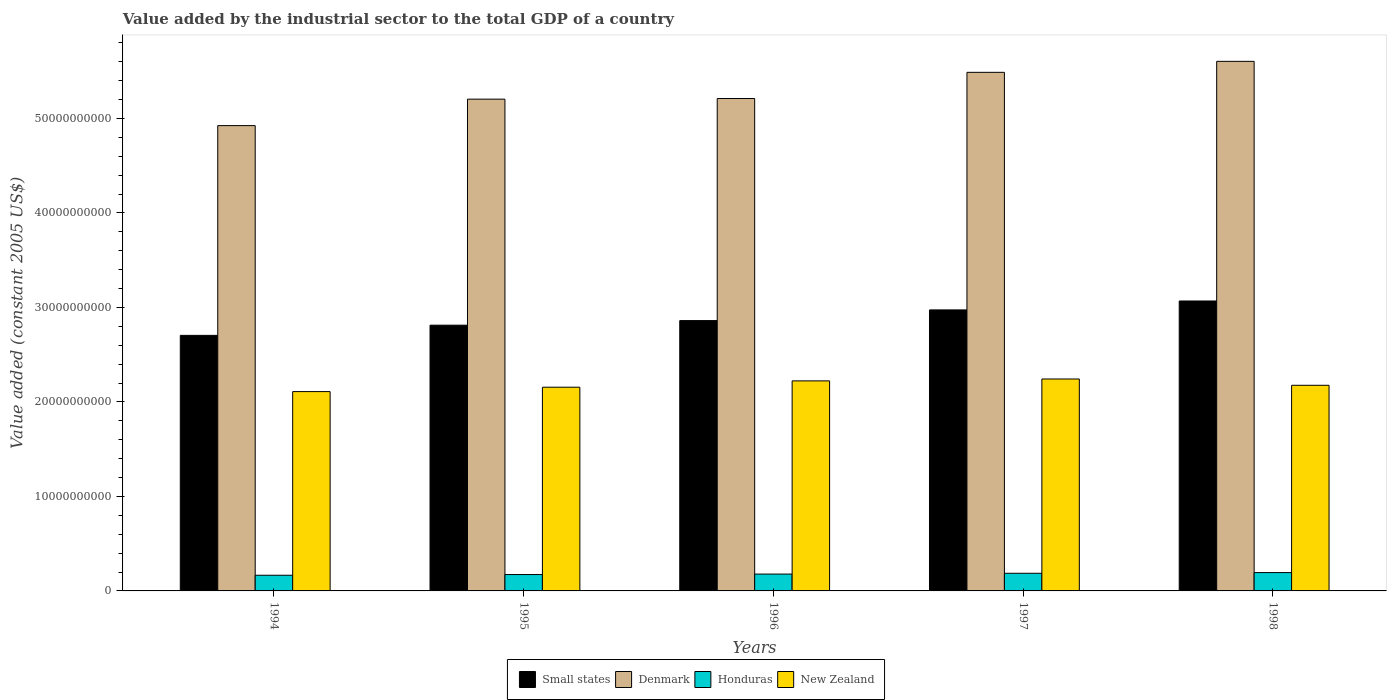How many different coloured bars are there?
Your answer should be compact. 4. Are the number of bars on each tick of the X-axis equal?
Offer a terse response. Yes. How many bars are there on the 2nd tick from the left?
Your answer should be compact. 4. In how many cases, is the number of bars for a given year not equal to the number of legend labels?
Provide a short and direct response. 0. What is the value added by the industrial sector in Small states in 1997?
Give a very brief answer. 2.97e+1. Across all years, what is the maximum value added by the industrial sector in Small states?
Provide a succinct answer. 3.07e+1. Across all years, what is the minimum value added by the industrial sector in Small states?
Provide a succinct answer. 2.70e+1. In which year was the value added by the industrial sector in Denmark minimum?
Offer a terse response. 1994. What is the total value added by the industrial sector in New Zealand in the graph?
Keep it short and to the point. 1.09e+11. What is the difference between the value added by the industrial sector in Small states in 1994 and that in 1997?
Your answer should be compact. -2.69e+09. What is the difference between the value added by the industrial sector in Denmark in 1998 and the value added by the industrial sector in Honduras in 1994?
Your response must be concise. 5.44e+1. What is the average value added by the industrial sector in New Zealand per year?
Make the answer very short. 2.18e+1. In the year 1996, what is the difference between the value added by the industrial sector in Denmark and value added by the industrial sector in Small states?
Your response must be concise. 2.35e+1. In how many years, is the value added by the industrial sector in Small states greater than 30000000000 US$?
Give a very brief answer. 1. What is the ratio of the value added by the industrial sector in New Zealand in 1994 to that in 1995?
Offer a very short reply. 0.98. Is the difference between the value added by the industrial sector in Denmark in 1997 and 1998 greater than the difference between the value added by the industrial sector in Small states in 1997 and 1998?
Your answer should be compact. No. What is the difference between the highest and the second highest value added by the industrial sector in Honduras?
Give a very brief answer. 7.31e+07. What is the difference between the highest and the lowest value added by the industrial sector in Honduras?
Your response must be concise. 2.81e+08. In how many years, is the value added by the industrial sector in New Zealand greater than the average value added by the industrial sector in New Zealand taken over all years?
Offer a terse response. 2. Is the sum of the value added by the industrial sector in Denmark in 1994 and 1998 greater than the maximum value added by the industrial sector in New Zealand across all years?
Give a very brief answer. Yes. Is it the case that in every year, the sum of the value added by the industrial sector in Denmark and value added by the industrial sector in New Zealand is greater than the sum of value added by the industrial sector in Honduras and value added by the industrial sector in Small states?
Keep it short and to the point. Yes. What does the 1st bar from the left in 1997 represents?
Your response must be concise. Small states. What does the 1st bar from the right in 1998 represents?
Offer a terse response. New Zealand. Are the values on the major ticks of Y-axis written in scientific E-notation?
Ensure brevity in your answer.  No. Where does the legend appear in the graph?
Your answer should be very brief. Bottom center. How many legend labels are there?
Your answer should be compact. 4. How are the legend labels stacked?
Your answer should be compact. Horizontal. What is the title of the graph?
Ensure brevity in your answer.  Value added by the industrial sector to the total GDP of a country. Does "Tajikistan" appear as one of the legend labels in the graph?
Offer a terse response. No. What is the label or title of the Y-axis?
Make the answer very short. Value added (constant 2005 US$). What is the Value added (constant 2005 US$) in Small states in 1994?
Make the answer very short. 2.70e+1. What is the Value added (constant 2005 US$) of Denmark in 1994?
Provide a short and direct response. 4.92e+1. What is the Value added (constant 2005 US$) in Honduras in 1994?
Give a very brief answer. 1.66e+09. What is the Value added (constant 2005 US$) of New Zealand in 1994?
Offer a very short reply. 2.11e+1. What is the Value added (constant 2005 US$) of Small states in 1995?
Make the answer very short. 2.81e+1. What is the Value added (constant 2005 US$) in Denmark in 1995?
Keep it short and to the point. 5.20e+1. What is the Value added (constant 2005 US$) in Honduras in 1995?
Your answer should be very brief. 1.73e+09. What is the Value added (constant 2005 US$) in New Zealand in 1995?
Your response must be concise. 2.16e+1. What is the Value added (constant 2005 US$) in Small states in 1996?
Provide a short and direct response. 2.86e+1. What is the Value added (constant 2005 US$) in Denmark in 1996?
Your answer should be compact. 5.21e+1. What is the Value added (constant 2005 US$) in Honduras in 1996?
Your response must be concise. 1.78e+09. What is the Value added (constant 2005 US$) of New Zealand in 1996?
Provide a short and direct response. 2.22e+1. What is the Value added (constant 2005 US$) in Small states in 1997?
Provide a succinct answer. 2.97e+1. What is the Value added (constant 2005 US$) in Denmark in 1997?
Your response must be concise. 5.49e+1. What is the Value added (constant 2005 US$) in Honduras in 1997?
Ensure brevity in your answer.  1.87e+09. What is the Value added (constant 2005 US$) of New Zealand in 1997?
Your answer should be very brief. 2.24e+1. What is the Value added (constant 2005 US$) in Small states in 1998?
Offer a terse response. 3.07e+1. What is the Value added (constant 2005 US$) of Denmark in 1998?
Your answer should be very brief. 5.60e+1. What is the Value added (constant 2005 US$) of Honduras in 1998?
Give a very brief answer. 1.94e+09. What is the Value added (constant 2005 US$) in New Zealand in 1998?
Give a very brief answer. 2.18e+1. Across all years, what is the maximum Value added (constant 2005 US$) of Small states?
Keep it short and to the point. 3.07e+1. Across all years, what is the maximum Value added (constant 2005 US$) in Denmark?
Your answer should be very brief. 5.60e+1. Across all years, what is the maximum Value added (constant 2005 US$) in Honduras?
Your response must be concise. 1.94e+09. Across all years, what is the maximum Value added (constant 2005 US$) of New Zealand?
Your response must be concise. 2.24e+1. Across all years, what is the minimum Value added (constant 2005 US$) in Small states?
Keep it short and to the point. 2.70e+1. Across all years, what is the minimum Value added (constant 2005 US$) of Denmark?
Your answer should be compact. 4.92e+1. Across all years, what is the minimum Value added (constant 2005 US$) in Honduras?
Provide a short and direct response. 1.66e+09. Across all years, what is the minimum Value added (constant 2005 US$) in New Zealand?
Make the answer very short. 2.11e+1. What is the total Value added (constant 2005 US$) in Small states in the graph?
Give a very brief answer. 1.44e+11. What is the total Value added (constant 2005 US$) of Denmark in the graph?
Offer a terse response. 2.64e+11. What is the total Value added (constant 2005 US$) in Honduras in the graph?
Ensure brevity in your answer.  8.98e+09. What is the total Value added (constant 2005 US$) in New Zealand in the graph?
Your answer should be compact. 1.09e+11. What is the difference between the Value added (constant 2005 US$) of Small states in 1994 and that in 1995?
Give a very brief answer. -1.08e+09. What is the difference between the Value added (constant 2005 US$) of Denmark in 1994 and that in 1995?
Provide a short and direct response. -2.80e+09. What is the difference between the Value added (constant 2005 US$) in Honduras in 1994 and that in 1995?
Ensure brevity in your answer.  -7.44e+07. What is the difference between the Value added (constant 2005 US$) of New Zealand in 1994 and that in 1995?
Your answer should be very brief. -4.64e+08. What is the difference between the Value added (constant 2005 US$) in Small states in 1994 and that in 1996?
Provide a short and direct response. -1.56e+09. What is the difference between the Value added (constant 2005 US$) in Denmark in 1994 and that in 1996?
Ensure brevity in your answer.  -2.87e+09. What is the difference between the Value added (constant 2005 US$) of Honduras in 1994 and that in 1996?
Give a very brief answer. -1.24e+08. What is the difference between the Value added (constant 2005 US$) of New Zealand in 1994 and that in 1996?
Your response must be concise. -1.13e+09. What is the difference between the Value added (constant 2005 US$) in Small states in 1994 and that in 1997?
Your answer should be very brief. -2.69e+09. What is the difference between the Value added (constant 2005 US$) in Denmark in 1994 and that in 1997?
Keep it short and to the point. -5.64e+09. What is the difference between the Value added (constant 2005 US$) in Honduras in 1994 and that in 1997?
Your answer should be very brief. -2.08e+08. What is the difference between the Value added (constant 2005 US$) in New Zealand in 1994 and that in 1997?
Your response must be concise. -1.33e+09. What is the difference between the Value added (constant 2005 US$) of Small states in 1994 and that in 1998?
Your answer should be very brief. -3.64e+09. What is the difference between the Value added (constant 2005 US$) in Denmark in 1994 and that in 1998?
Your response must be concise. -6.80e+09. What is the difference between the Value added (constant 2005 US$) of Honduras in 1994 and that in 1998?
Offer a terse response. -2.81e+08. What is the difference between the Value added (constant 2005 US$) of New Zealand in 1994 and that in 1998?
Provide a short and direct response. -6.67e+08. What is the difference between the Value added (constant 2005 US$) of Small states in 1995 and that in 1996?
Make the answer very short. -4.87e+08. What is the difference between the Value added (constant 2005 US$) in Denmark in 1995 and that in 1996?
Ensure brevity in your answer.  -6.66e+07. What is the difference between the Value added (constant 2005 US$) in Honduras in 1995 and that in 1996?
Your response must be concise. -5.00e+07. What is the difference between the Value added (constant 2005 US$) in New Zealand in 1995 and that in 1996?
Keep it short and to the point. -6.70e+08. What is the difference between the Value added (constant 2005 US$) in Small states in 1995 and that in 1997?
Your answer should be very brief. -1.62e+09. What is the difference between the Value added (constant 2005 US$) in Denmark in 1995 and that in 1997?
Your response must be concise. -2.84e+09. What is the difference between the Value added (constant 2005 US$) of Honduras in 1995 and that in 1997?
Provide a succinct answer. -1.33e+08. What is the difference between the Value added (constant 2005 US$) of New Zealand in 1995 and that in 1997?
Offer a terse response. -8.70e+08. What is the difference between the Value added (constant 2005 US$) in Small states in 1995 and that in 1998?
Your answer should be compact. -2.56e+09. What is the difference between the Value added (constant 2005 US$) in Denmark in 1995 and that in 1998?
Your answer should be compact. -4.00e+09. What is the difference between the Value added (constant 2005 US$) in Honduras in 1995 and that in 1998?
Give a very brief answer. -2.07e+08. What is the difference between the Value added (constant 2005 US$) in New Zealand in 1995 and that in 1998?
Offer a terse response. -2.04e+08. What is the difference between the Value added (constant 2005 US$) in Small states in 1996 and that in 1997?
Ensure brevity in your answer.  -1.13e+09. What is the difference between the Value added (constant 2005 US$) in Denmark in 1996 and that in 1997?
Your answer should be very brief. -2.77e+09. What is the difference between the Value added (constant 2005 US$) of Honduras in 1996 and that in 1997?
Provide a short and direct response. -8.34e+07. What is the difference between the Value added (constant 2005 US$) in New Zealand in 1996 and that in 1997?
Offer a terse response. -2.00e+08. What is the difference between the Value added (constant 2005 US$) of Small states in 1996 and that in 1998?
Ensure brevity in your answer.  -2.07e+09. What is the difference between the Value added (constant 2005 US$) in Denmark in 1996 and that in 1998?
Make the answer very short. -3.93e+09. What is the difference between the Value added (constant 2005 US$) of Honduras in 1996 and that in 1998?
Your answer should be compact. -1.57e+08. What is the difference between the Value added (constant 2005 US$) of New Zealand in 1996 and that in 1998?
Offer a terse response. 4.66e+08. What is the difference between the Value added (constant 2005 US$) of Small states in 1997 and that in 1998?
Your answer should be very brief. -9.44e+08. What is the difference between the Value added (constant 2005 US$) of Denmark in 1997 and that in 1998?
Provide a succinct answer. -1.16e+09. What is the difference between the Value added (constant 2005 US$) of Honduras in 1997 and that in 1998?
Your answer should be compact. -7.31e+07. What is the difference between the Value added (constant 2005 US$) of New Zealand in 1997 and that in 1998?
Offer a terse response. 6.66e+08. What is the difference between the Value added (constant 2005 US$) of Small states in 1994 and the Value added (constant 2005 US$) of Denmark in 1995?
Ensure brevity in your answer.  -2.50e+1. What is the difference between the Value added (constant 2005 US$) in Small states in 1994 and the Value added (constant 2005 US$) in Honduras in 1995?
Keep it short and to the point. 2.53e+1. What is the difference between the Value added (constant 2005 US$) in Small states in 1994 and the Value added (constant 2005 US$) in New Zealand in 1995?
Ensure brevity in your answer.  5.49e+09. What is the difference between the Value added (constant 2005 US$) in Denmark in 1994 and the Value added (constant 2005 US$) in Honduras in 1995?
Your answer should be very brief. 4.75e+1. What is the difference between the Value added (constant 2005 US$) of Denmark in 1994 and the Value added (constant 2005 US$) of New Zealand in 1995?
Ensure brevity in your answer.  2.77e+1. What is the difference between the Value added (constant 2005 US$) of Honduras in 1994 and the Value added (constant 2005 US$) of New Zealand in 1995?
Your answer should be very brief. -1.99e+1. What is the difference between the Value added (constant 2005 US$) in Small states in 1994 and the Value added (constant 2005 US$) in Denmark in 1996?
Ensure brevity in your answer.  -2.51e+1. What is the difference between the Value added (constant 2005 US$) in Small states in 1994 and the Value added (constant 2005 US$) in Honduras in 1996?
Keep it short and to the point. 2.53e+1. What is the difference between the Value added (constant 2005 US$) in Small states in 1994 and the Value added (constant 2005 US$) in New Zealand in 1996?
Provide a succinct answer. 4.82e+09. What is the difference between the Value added (constant 2005 US$) in Denmark in 1994 and the Value added (constant 2005 US$) in Honduras in 1996?
Give a very brief answer. 4.75e+1. What is the difference between the Value added (constant 2005 US$) in Denmark in 1994 and the Value added (constant 2005 US$) in New Zealand in 1996?
Provide a succinct answer. 2.70e+1. What is the difference between the Value added (constant 2005 US$) of Honduras in 1994 and the Value added (constant 2005 US$) of New Zealand in 1996?
Keep it short and to the point. -2.06e+1. What is the difference between the Value added (constant 2005 US$) in Small states in 1994 and the Value added (constant 2005 US$) in Denmark in 1997?
Your answer should be compact. -2.78e+1. What is the difference between the Value added (constant 2005 US$) in Small states in 1994 and the Value added (constant 2005 US$) in Honduras in 1997?
Ensure brevity in your answer.  2.52e+1. What is the difference between the Value added (constant 2005 US$) in Small states in 1994 and the Value added (constant 2005 US$) in New Zealand in 1997?
Ensure brevity in your answer.  4.62e+09. What is the difference between the Value added (constant 2005 US$) of Denmark in 1994 and the Value added (constant 2005 US$) of Honduras in 1997?
Offer a terse response. 4.74e+1. What is the difference between the Value added (constant 2005 US$) in Denmark in 1994 and the Value added (constant 2005 US$) in New Zealand in 1997?
Give a very brief answer. 2.68e+1. What is the difference between the Value added (constant 2005 US$) of Honduras in 1994 and the Value added (constant 2005 US$) of New Zealand in 1997?
Your response must be concise. -2.08e+1. What is the difference between the Value added (constant 2005 US$) of Small states in 1994 and the Value added (constant 2005 US$) of Denmark in 1998?
Provide a succinct answer. -2.90e+1. What is the difference between the Value added (constant 2005 US$) in Small states in 1994 and the Value added (constant 2005 US$) in Honduras in 1998?
Your response must be concise. 2.51e+1. What is the difference between the Value added (constant 2005 US$) of Small states in 1994 and the Value added (constant 2005 US$) of New Zealand in 1998?
Keep it short and to the point. 5.28e+09. What is the difference between the Value added (constant 2005 US$) of Denmark in 1994 and the Value added (constant 2005 US$) of Honduras in 1998?
Offer a terse response. 4.73e+1. What is the difference between the Value added (constant 2005 US$) of Denmark in 1994 and the Value added (constant 2005 US$) of New Zealand in 1998?
Ensure brevity in your answer.  2.75e+1. What is the difference between the Value added (constant 2005 US$) in Honduras in 1994 and the Value added (constant 2005 US$) in New Zealand in 1998?
Keep it short and to the point. -2.01e+1. What is the difference between the Value added (constant 2005 US$) of Small states in 1995 and the Value added (constant 2005 US$) of Denmark in 1996?
Provide a succinct answer. -2.40e+1. What is the difference between the Value added (constant 2005 US$) in Small states in 1995 and the Value added (constant 2005 US$) in Honduras in 1996?
Your answer should be very brief. 2.63e+1. What is the difference between the Value added (constant 2005 US$) of Small states in 1995 and the Value added (constant 2005 US$) of New Zealand in 1996?
Offer a terse response. 5.89e+09. What is the difference between the Value added (constant 2005 US$) of Denmark in 1995 and the Value added (constant 2005 US$) of Honduras in 1996?
Offer a very short reply. 5.03e+1. What is the difference between the Value added (constant 2005 US$) in Denmark in 1995 and the Value added (constant 2005 US$) in New Zealand in 1996?
Provide a short and direct response. 2.98e+1. What is the difference between the Value added (constant 2005 US$) of Honduras in 1995 and the Value added (constant 2005 US$) of New Zealand in 1996?
Ensure brevity in your answer.  -2.05e+1. What is the difference between the Value added (constant 2005 US$) in Small states in 1995 and the Value added (constant 2005 US$) in Denmark in 1997?
Provide a short and direct response. -2.68e+1. What is the difference between the Value added (constant 2005 US$) in Small states in 1995 and the Value added (constant 2005 US$) in Honduras in 1997?
Provide a short and direct response. 2.63e+1. What is the difference between the Value added (constant 2005 US$) of Small states in 1995 and the Value added (constant 2005 US$) of New Zealand in 1997?
Offer a very short reply. 5.69e+09. What is the difference between the Value added (constant 2005 US$) of Denmark in 1995 and the Value added (constant 2005 US$) of Honduras in 1997?
Provide a short and direct response. 5.02e+1. What is the difference between the Value added (constant 2005 US$) of Denmark in 1995 and the Value added (constant 2005 US$) of New Zealand in 1997?
Keep it short and to the point. 2.96e+1. What is the difference between the Value added (constant 2005 US$) of Honduras in 1995 and the Value added (constant 2005 US$) of New Zealand in 1997?
Your answer should be very brief. -2.07e+1. What is the difference between the Value added (constant 2005 US$) in Small states in 1995 and the Value added (constant 2005 US$) in Denmark in 1998?
Give a very brief answer. -2.79e+1. What is the difference between the Value added (constant 2005 US$) of Small states in 1995 and the Value added (constant 2005 US$) of Honduras in 1998?
Make the answer very short. 2.62e+1. What is the difference between the Value added (constant 2005 US$) in Small states in 1995 and the Value added (constant 2005 US$) in New Zealand in 1998?
Keep it short and to the point. 6.36e+09. What is the difference between the Value added (constant 2005 US$) in Denmark in 1995 and the Value added (constant 2005 US$) in Honduras in 1998?
Offer a very short reply. 5.01e+1. What is the difference between the Value added (constant 2005 US$) in Denmark in 1995 and the Value added (constant 2005 US$) in New Zealand in 1998?
Make the answer very short. 3.03e+1. What is the difference between the Value added (constant 2005 US$) of Honduras in 1995 and the Value added (constant 2005 US$) of New Zealand in 1998?
Give a very brief answer. -2.00e+1. What is the difference between the Value added (constant 2005 US$) in Small states in 1996 and the Value added (constant 2005 US$) in Denmark in 1997?
Provide a short and direct response. -2.63e+1. What is the difference between the Value added (constant 2005 US$) of Small states in 1996 and the Value added (constant 2005 US$) of Honduras in 1997?
Your answer should be compact. 2.67e+1. What is the difference between the Value added (constant 2005 US$) in Small states in 1996 and the Value added (constant 2005 US$) in New Zealand in 1997?
Make the answer very short. 6.18e+09. What is the difference between the Value added (constant 2005 US$) of Denmark in 1996 and the Value added (constant 2005 US$) of Honduras in 1997?
Provide a short and direct response. 5.02e+1. What is the difference between the Value added (constant 2005 US$) of Denmark in 1996 and the Value added (constant 2005 US$) of New Zealand in 1997?
Ensure brevity in your answer.  2.97e+1. What is the difference between the Value added (constant 2005 US$) in Honduras in 1996 and the Value added (constant 2005 US$) in New Zealand in 1997?
Your response must be concise. -2.06e+1. What is the difference between the Value added (constant 2005 US$) of Small states in 1996 and the Value added (constant 2005 US$) of Denmark in 1998?
Make the answer very short. -2.74e+1. What is the difference between the Value added (constant 2005 US$) of Small states in 1996 and the Value added (constant 2005 US$) of Honduras in 1998?
Give a very brief answer. 2.67e+1. What is the difference between the Value added (constant 2005 US$) in Small states in 1996 and the Value added (constant 2005 US$) in New Zealand in 1998?
Your answer should be compact. 6.85e+09. What is the difference between the Value added (constant 2005 US$) of Denmark in 1996 and the Value added (constant 2005 US$) of Honduras in 1998?
Your answer should be very brief. 5.02e+1. What is the difference between the Value added (constant 2005 US$) of Denmark in 1996 and the Value added (constant 2005 US$) of New Zealand in 1998?
Offer a very short reply. 3.03e+1. What is the difference between the Value added (constant 2005 US$) in Honduras in 1996 and the Value added (constant 2005 US$) in New Zealand in 1998?
Ensure brevity in your answer.  -2.00e+1. What is the difference between the Value added (constant 2005 US$) in Small states in 1997 and the Value added (constant 2005 US$) in Denmark in 1998?
Your answer should be compact. -2.63e+1. What is the difference between the Value added (constant 2005 US$) of Small states in 1997 and the Value added (constant 2005 US$) of Honduras in 1998?
Your answer should be compact. 2.78e+1. What is the difference between the Value added (constant 2005 US$) of Small states in 1997 and the Value added (constant 2005 US$) of New Zealand in 1998?
Ensure brevity in your answer.  7.98e+09. What is the difference between the Value added (constant 2005 US$) of Denmark in 1997 and the Value added (constant 2005 US$) of Honduras in 1998?
Your response must be concise. 5.29e+1. What is the difference between the Value added (constant 2005 US$) of Denmark in 1997 and the Value added (constant 2005 US$) of New Zealand in 1998?
Make the answer very short. 3.31e+1. What is the difference between the Value added (constant 2005 US$) of Honduras in 1997 and the Value added (constant 2005 US$) of New Zealand in 1998?
Give a very brief answer. -1.99e+1. What is the average Value added (constant 2005 US$) in Small states per year?
Give a very brief answer. 2.88e+1. What is the average Value added (constant 2005 US$) in Denmark per year?
Your answer should be compact. 5.29e+1. What is the average Value added (constant 2005 US$) in Honduras per year?
Keep it short and to the point. 1.80e+09. What is the average Value added (constant 2005 US$) in New Zealand per year?
Your response must be concise. 2.18e+1. In the year 1994, what is the difference between the Value added (constant 2005 US$) in Small states and Value added (constant 2005 US$) in Denmark?
Your response must be concise. -2.22e+1. In the year 1994, what is the difference between the Value added (constant 2005 US$) in Small states and Value added (constant 2005 US$) in Honduras?
Your answer should be compact. 2.54e+1. In the year 1994, what is the difference between the Value added (constant 2005 US$) of Small states and Value added (constant 2005 US$) of New Zealand?
Give a very brief answer. 5.95e+09. In the year 1994, what is the difference between the Value added (constant 2005 US$) of Denmark and Value added (constant 2005 US$) of Honduras?
Make the answer very short. 4.76e+1. In the year 1994, what is the difference between the Value added (constant 2005 US$) of Denmark and Value added (constant 2005 US$) of New Zealand?
Provide a short and direct response. 2.81e+1. In the year 1994, what is the difference between the Value added (constant 2005 US$) in Honduras and Value added (constant 2005 US$) in New Zealand?
Offer a terse response. -1.94e+1. In the year 1995, what is the difference between the Value added (constant 2005 US$) in Small states and Value added (constant 2005 US$) in Denmark?
Offer a very short reply. -2.39e+1. In the year 1995, what is the difference between the Value added (constant 2005 US$) of Small states and Value added (constant 2005 US$) of Honduras?
Ensure brevity in your answer.  2.64e+1. In the year 1995, what is the difference between the Value added (constant 2005 US$) of Small states and Value added (constant 2005 US$) of New Zealand?
Offer a terse response. 6.56e+09. In the year 1995, what is the difference between the Value added (constant 2005 US$) of Denmark and Value added (constant 2005 US$) of Honduras?
Keep it short and to the point. 5.03e+1. In the year 1995, what is the difference between the Value added (constant 2005 US$) in Denmark and Value added (constant 2005 US$) in New Zealand?
Your answer should be compact. 3.05e+1. In the year 1995, what is the difference between the Value added (constant 2005 US$) of Honduras and Value added (constant 2005 US$) of New Zealand?
Offer a terse response. -1.98e+1. In the year 1996, what is the difference between the Value added (constant 2005 US$) in Small states and Value added (constant 2005 US$) in Denmark?
Provide a succinct answer. -2.35e+1. In the year 1996, what is the difference between the Value added (constant 2005 US$) of Small states and Value added (constant 2005 US$) of Honduras?
Provide a short and direct response. 2.68e+1. In the year 1996, what is the difference between the Value added (constant 2005 US$) in Small states and Value added (constant 2005 US$) in New Zealand?
Keep it short and to the point. 6.38e+09. In the year 1996, what is the difference between the Value added (constant 2005 US$) of Denmark and Value added (constant 2005 US$) of Honduras?
Your answer should be very brief. 5.03e+1. In the year 1996, what is the difference between the Value added (constant 2005 US$) in Denmark and Value added (constant 2005 US$) in New Zealand?
Offer a very short reply. 2.99e+1. In the year 1996, what is the difference between the Value added (constant 2005 US$) of Honduras and Value added (constant 2005 US$) of New Zealand?
Ensure brevity in your answer.  -2.04e+1. In the year 1997, what is the difference between the Value added (constant 2005 US$) of Small states and Value added (constant 2005 US$) of Denmark?
Provide a succinct answer. -2.51e+1. In the year 1997, what is the difference between the Value added (constant 2005 US$) in Small states and Value added (constant 2005 US$) in Honduras?
Ensure brevity in your answer.  2.79e+1. In the year 1997, what is the difference between the Value added (constant 2005 US$) of Small states and Value added (constant 2005 US$) of New Zealand?
Give a very brief answer. 7.31e+09. In the year 1997, what is the difference between the Value added (constant 2005 US$) of Denmark and Value added (constant 2005 US$) of Honduras?
Keep it short and to the point. 5.30e+1. In the year 1997, what is the difference between the Value added (constant 2005 US$) in Denmark and Value added (constant 2005 US$) in New Zealand?
Offer a very short reply. 3.25e+1. In the year 1997, what is the difference between the Value added (constant 2005 US$) of Honduras and Value added (constant 2005 US$) of New Zealand?
Your answer should be very brief. -2.06e+1. In the year 1998, what is the difference between the Value added (constant 2005 US$) of Small states and Value added (constant 2005 US$) of Denmark?
Provide a short and direct response. -2.54e+1. In the year 1998, what is the difference between the Value added (constant 2005 US$) in Small states and Value added (constant 2005 US$) in Honduras?
Your answer should be very brief. 2.87e+1. In the year 1998, what is the difference between the Value added (constant 2005 US$) of Small states and Value added (constant 2005 US$) of New Zealand?
Provide a short and direct response. 8.92e+09. In the year 1998, what is the difference between the Value added (constant 2005 US$) of Denmark and Value added (constant 2005 US$) of Honduras?
Provide a short and direct response. 5.41e+1. In the year 1998, what is the difference between the Value added (constant 2005 US$) in Denmark and Value added (constant 2005 US$) in New Zealand?
Provide a short and direct response. 3.43e+1. In the year 1998, what is the difference between the Value added (constant 2005 US$) of Honduras and Value added (constant 2005 US$) of New Zealand?
Provide a short and direct response. -1.98e+1. What is the ratio of the Value added (constant 2005 US$) of Small states in 1994 to that in 1995?
Ensure brevity in your answer.  0.96. What is the ratio of the Value added (constant 2005 US$) in Denmark in 1994 to that in 1995?
Provide a succinct answer. 0.95. What is the ratio of the Value added (constant 2005 US$) of Honduras in 1994 to that in 1995?
Your answer should be compact. 0.96. What is the ratio of the Value added (constant 2005 US$) of New Zealand in 1994 to that in 1995?
Your answer should be compact. 0.98. What is the ratio of the Value added (constant 2005 US$) of Small states in 1994 to that in 1996?
Keep it short and to the point. 0.95. What is the ratio of the Value added (constant 2005 US$) in Denmark in 1994 to that in 1996?
Your response must be concise. 0.94. What is the ratio of the Value added (constant 2005 US$) of Honduras in 1994 to that in 1996?
Give a very brief answer. 0.93. What is the ratio of the Value added (constant 2005 US$) of New Zealand in 1994 to that in 1996?
Offer a terse response. 0.95. What is the ratio of the Value added (constant 2005 US$) of Small states in 1994 to that in 1997?
Your answer should be very brief. 0.91. What is the ratio of the Value added (constant 2005 US$) in Denmark in 1994 to that in 1997?
Give a very brief answer. 0.9. What is the ratio of the Value added (constant 2005 US$) of Honduras in 1994 to that in 1997?
Your answer should be very brief. 0.89. What is the ratio of the Value added (constant 2005 US$) in New Zealand in 1994 to that in 1997?
Make the answer very short. 0.94. What is the ratio of the Value added (constant 2005 US$) in Small states in 1994 to that in 1998?
Offer a very short reply. 0.88. What is the ratio of the Value added (constant 2005 US$) in Denmark in 1994 to that in 1998?
Offer a very short reply. 0.88. What is the ratio of the Value added (constant 2005 US$) in Honduras in 1994 to that in 1998?
Offer a very short reply. 0.86. What is the ratio of the Value added (constant 2005 US$) in New Zealand in 1994 to that in 1998?
Offer a very short reply. 0.97. What is the ratio of the Value added (constant 2005 US$) in Denmark in 1995 to that in 1996?
Give a very brief answer. 1. What is the ratio of the Value added (constant 2005 US$) in Honduras in 1995 to that in 1996?
Your answer should be compact. 0.97. What is the ratio of the Value added (constant 2005 US$) in New Zealand in 1995 to that in 1996?
Make the answer very short. 0.97. What is the ratio of the Value added (constant 2005 US$) in Small states in 1995 to that in 1997?
Offer a terse response. 0.95. What is the ratio of the Value added (constant 2005 US$) of Denmark in 1995 to that in 1997?
Keep it short and to the point. 0.95. What is the ratio of the Value added (constant 2005 US$) of Honduras in 1995 to that in 1997?
Offer a terse response. 0.93. What is the ratio of the Value added (constant 2005 US$) of New Zealand in 1995 to that in 1997?
Provide a succinct answer. 0.96. What is the ratio of the Value added (constant 2005 US$) of Small states in 1995 to that in 1998?
Provide a succinct answer. 0.92. What is the ratio of the Value added (constant 2005 US$) in Honduras in 1995 to that in 1998?
Provide a short and direct response. 0.89. What is the ratio of the Value added (constant 2005 US$) in New Zealand in 1995 to that in 1998?
Provide a succinct answer. 0.99. What is the ratio of the Value added (constant 2005 US$) of Denmark in 1996 to that in 1997?
Make the answer very short. 0.95. What is the ratio of the Value added (constant 2005 US$) in Honduras in 1996 to that in 1997?
Offer a terse response. 0.96. What is the ratio of the Value added (constant 2005 US$) in New Zealand in 1996 to that in 1997?
Your response must be concise. 0.99. What is the ratio of the Value added (constant 2005 US$) in Small states in 1996 to that in 1998?
Offer a terse response. 0.93. What is the ratio of the Value added (constant 2005 US$) of Denmark in 1996 to that in 1998?
Your answer should be very brief. 0.93. What is the ratio of the Value added (constant 2005 US$) in Honduras in 1996 to that in 1998?
Make the answer very short. 0.92. What is the ratio of the Value added (constant 2005 US$) of New Zealand in 1996 to that in 1998?
Offer a very short reply. 1.02. What is the ratio of the Value added (constant 2005 US$) of Small states in 1997 to that in 1998?
Ensure brevity in your answer.  0.97. What is the ratio of the Value added (constant 2005 US$) in Denmark in 1997 to that in 1998?
Make the answer very short. 0.98. What is the ratio of the Value added (constant 2005 US$) in Honduras in 1997 to that in 1998?
Your answer should be very brief. 0.96. What is the ratio of the Value added (constant 2005 US$) of New Zealand in 1997 to that in 1998?
Your answer should be compact. 1.03. What is the difference between the highest and the second highest Value added (constant 2005 US$) in Small states?
Your answer should be compact. 9.44e+08. What is the difference between the highest and the second highest Value added (constant 2005 US$) of Denmark?
Your answer should be compact. 1.16e+09. What is the difference between the highest and the second highest Value added (constant 2005 US$) of Honduras?
Offer a terse response. 7.31e+07. What is the difference between the highest and the second highest Value added (constant 2005 US$) of New Zealand?
Your answer should be very brief. 2.00e+08. What is the difference between the highest and the lowest Value added (constant 2005 US$) of Small states?
Provide a short and direct response. 3.64e+09. What is the difference between the highest and the lowest Value added (constant 2005 US$) of Denmark?
Your answer should be very brief. 6.80e+09. What is the difference between the highest and the lowest Value added (constant 2005 US$) of Honduras?
Your response must be concise. 2.81e+08. What is the difference between the highest and the lowest Value added (constant 2005 US$) in New Zealand?
Your answer should be very brief. 1.33e+09. 